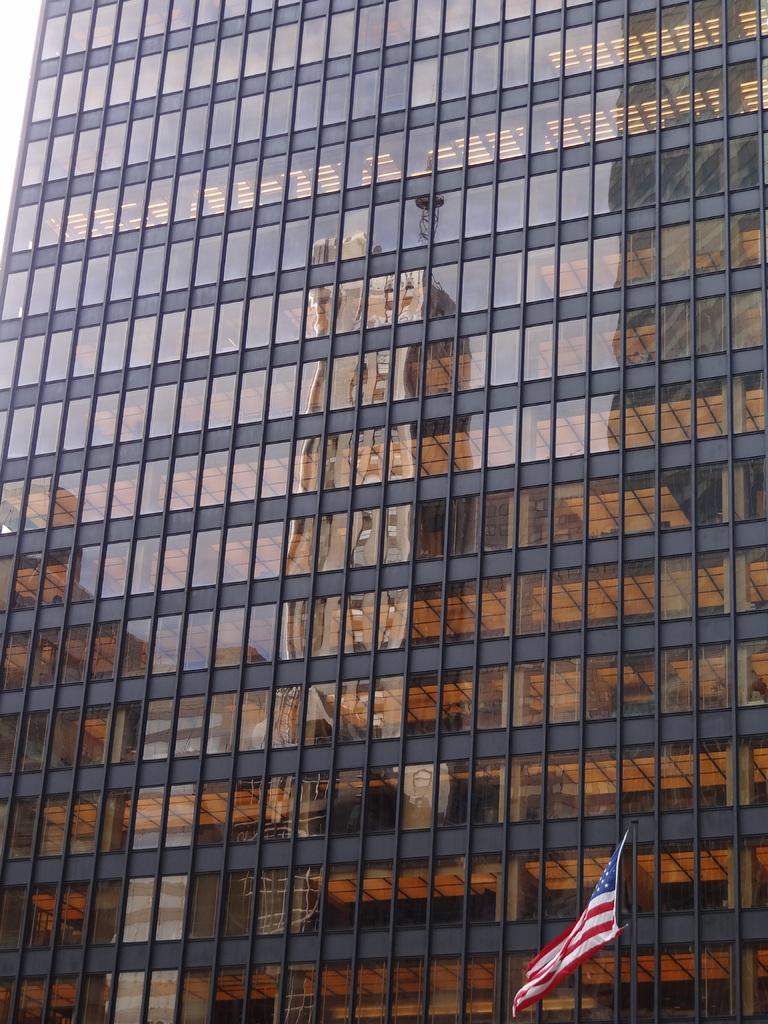What type of structure is present in the image? There is a building in the image. What feature can be observed on the building? The building has glass windows. What additional element is present in the image? There is a flag in the image. How many times does the tooth sneeze in the image? There is no tooth or sneezing present in the image. What is the name of the place where the building is located in the image? The provided facts do not include any information about the location or name of the place where the building is situated. 